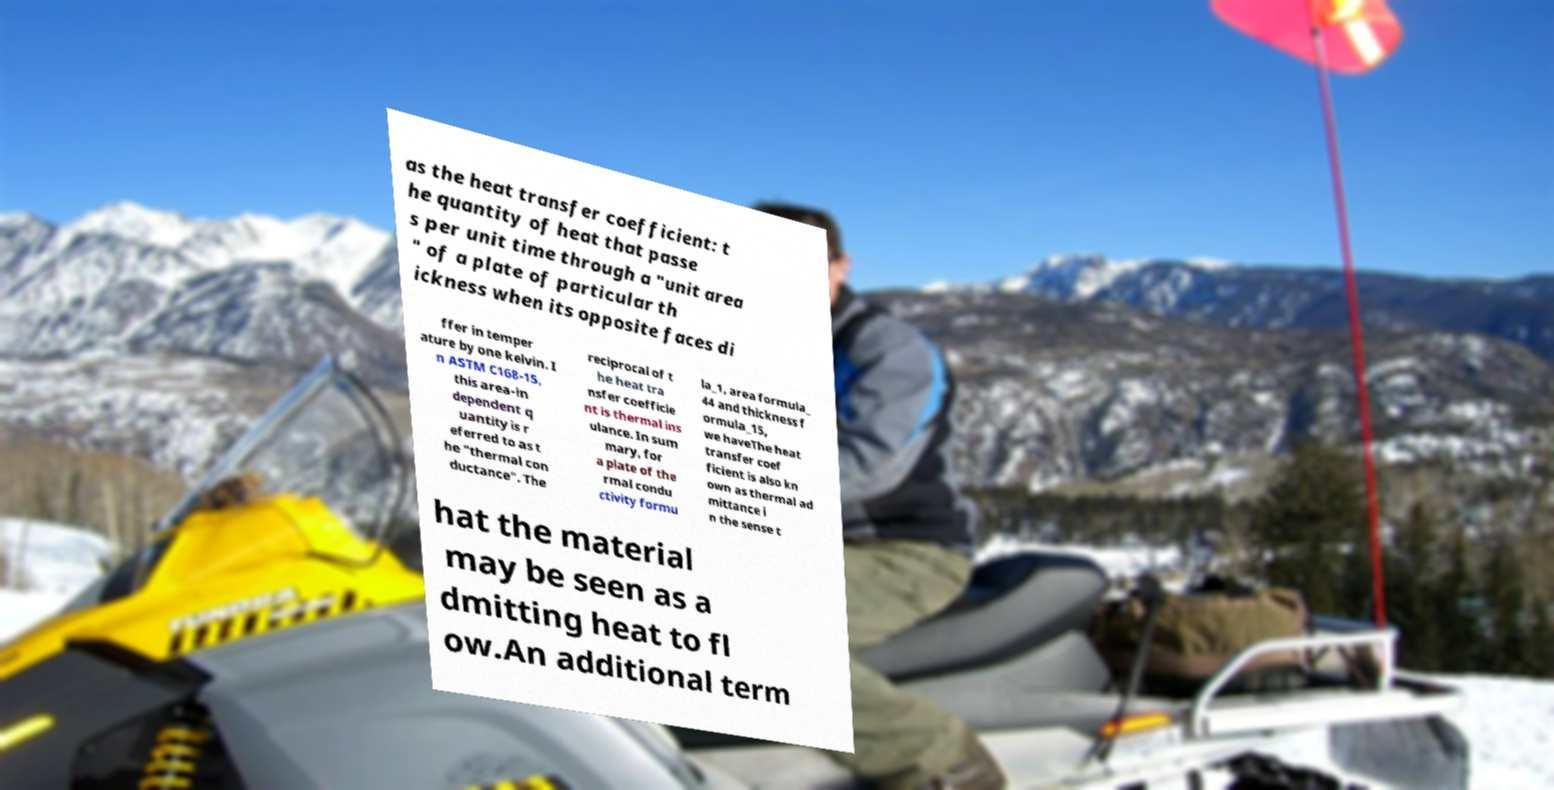Please identify and transcribe the text found in this image. as the heat transfer coefficient: t he quantity of heat that passe s per unit time through a "unit area " of a plate of particular th ickness when its opposite faces di ffer in temper ature by one kelvin. I n ASTM C168-15, this area-in dependent q uantity is r eferred to as t he "thermal con ductance". The reciprocal of t he heat tra nsfer coefficie nt is thermal ins ulance. In sum mary, for a plate of the rmal condu ctivity formu la_1, area formula_ 44 and thickness f ormula_15, we haveThe heat transfer coef ficient is also kn own as thermal ad mittance i n the sense t hat the material may be seen as a dmitting heat to fl ow.An additional term 